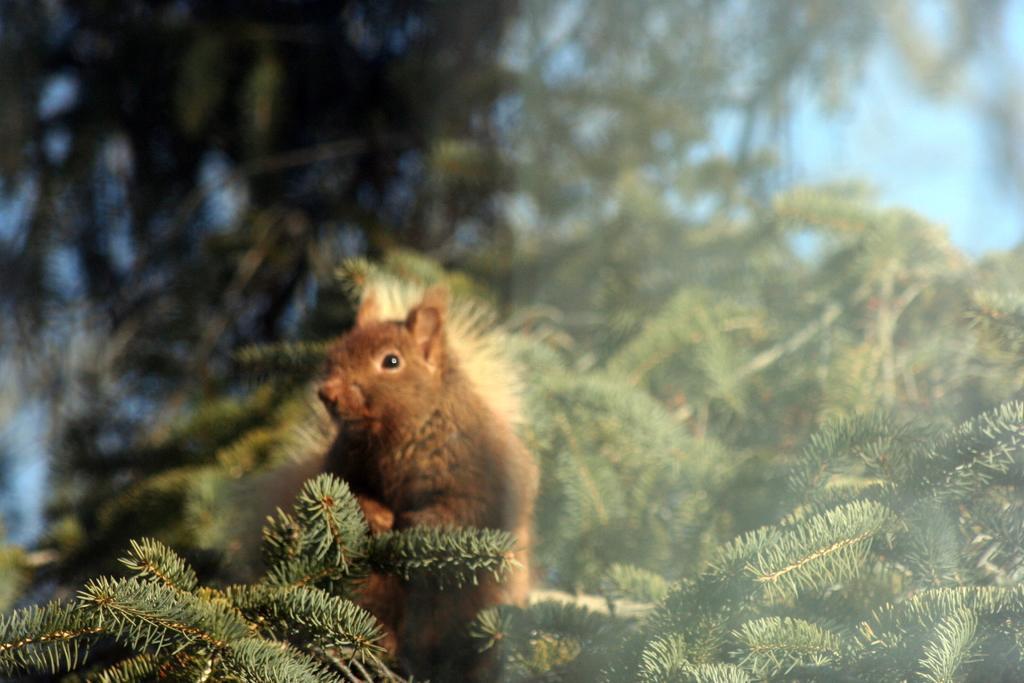Describe this image in one or two sentences. In this image I can see number of trees and in the front I can see a brown coloured squirrel. I can also see the sky in the background and I can see this image is little bit blurry. 